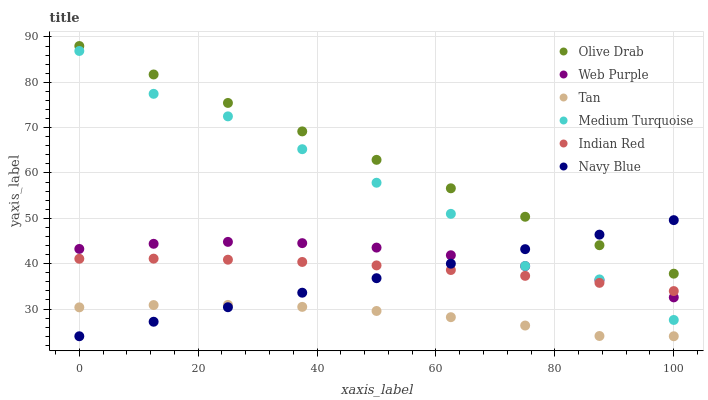Does Tan have the minimum area under the curve?
Answer yes or no. Yes. Does Olive Drab have the maximum area under the curve?
Answer yes or no. Yes. Does Navy Blue have the minimum area under the curve?
Answer yes or no. No. Does Navy Blue have the maximum area under the curve?
Answer yes or no. No. Is Navy Blue the smoothest?
Answer yes or no. Yes. Is Medium Turquoise the roughest?
Answer yes or no. Yes. Is Web Purple the smoothest?
Answer yes or no. No. Is Web Purple the roughest?
Answer yes or no. No. Does Navy Blue have the lowest value?
Answer yes or no. Yes. Does Web Purple have the lowest value?
Answer yes or no. No. Does Olive Drab have the highest value?
Answer yes or no. Yes. Does Navy Blue have the highest value?
Answer yes or no. No. Is Medium Turquoise less than Olive Drab?
Answer yes or no. Yes. Is Olive Drab greater than Indian Red?
Answer yes or no. Yes. Does Web Purple intersect Navy Blue?
Answer yes or no. Yes. Is Web Purple less than Navy Blue?
Answer yes or no. No. Is Web Purple greater than Navy Blue?
Answer yes or no. No. Does Medium Turquoise intersect Olive Drab?
Answer yes or no. No. 